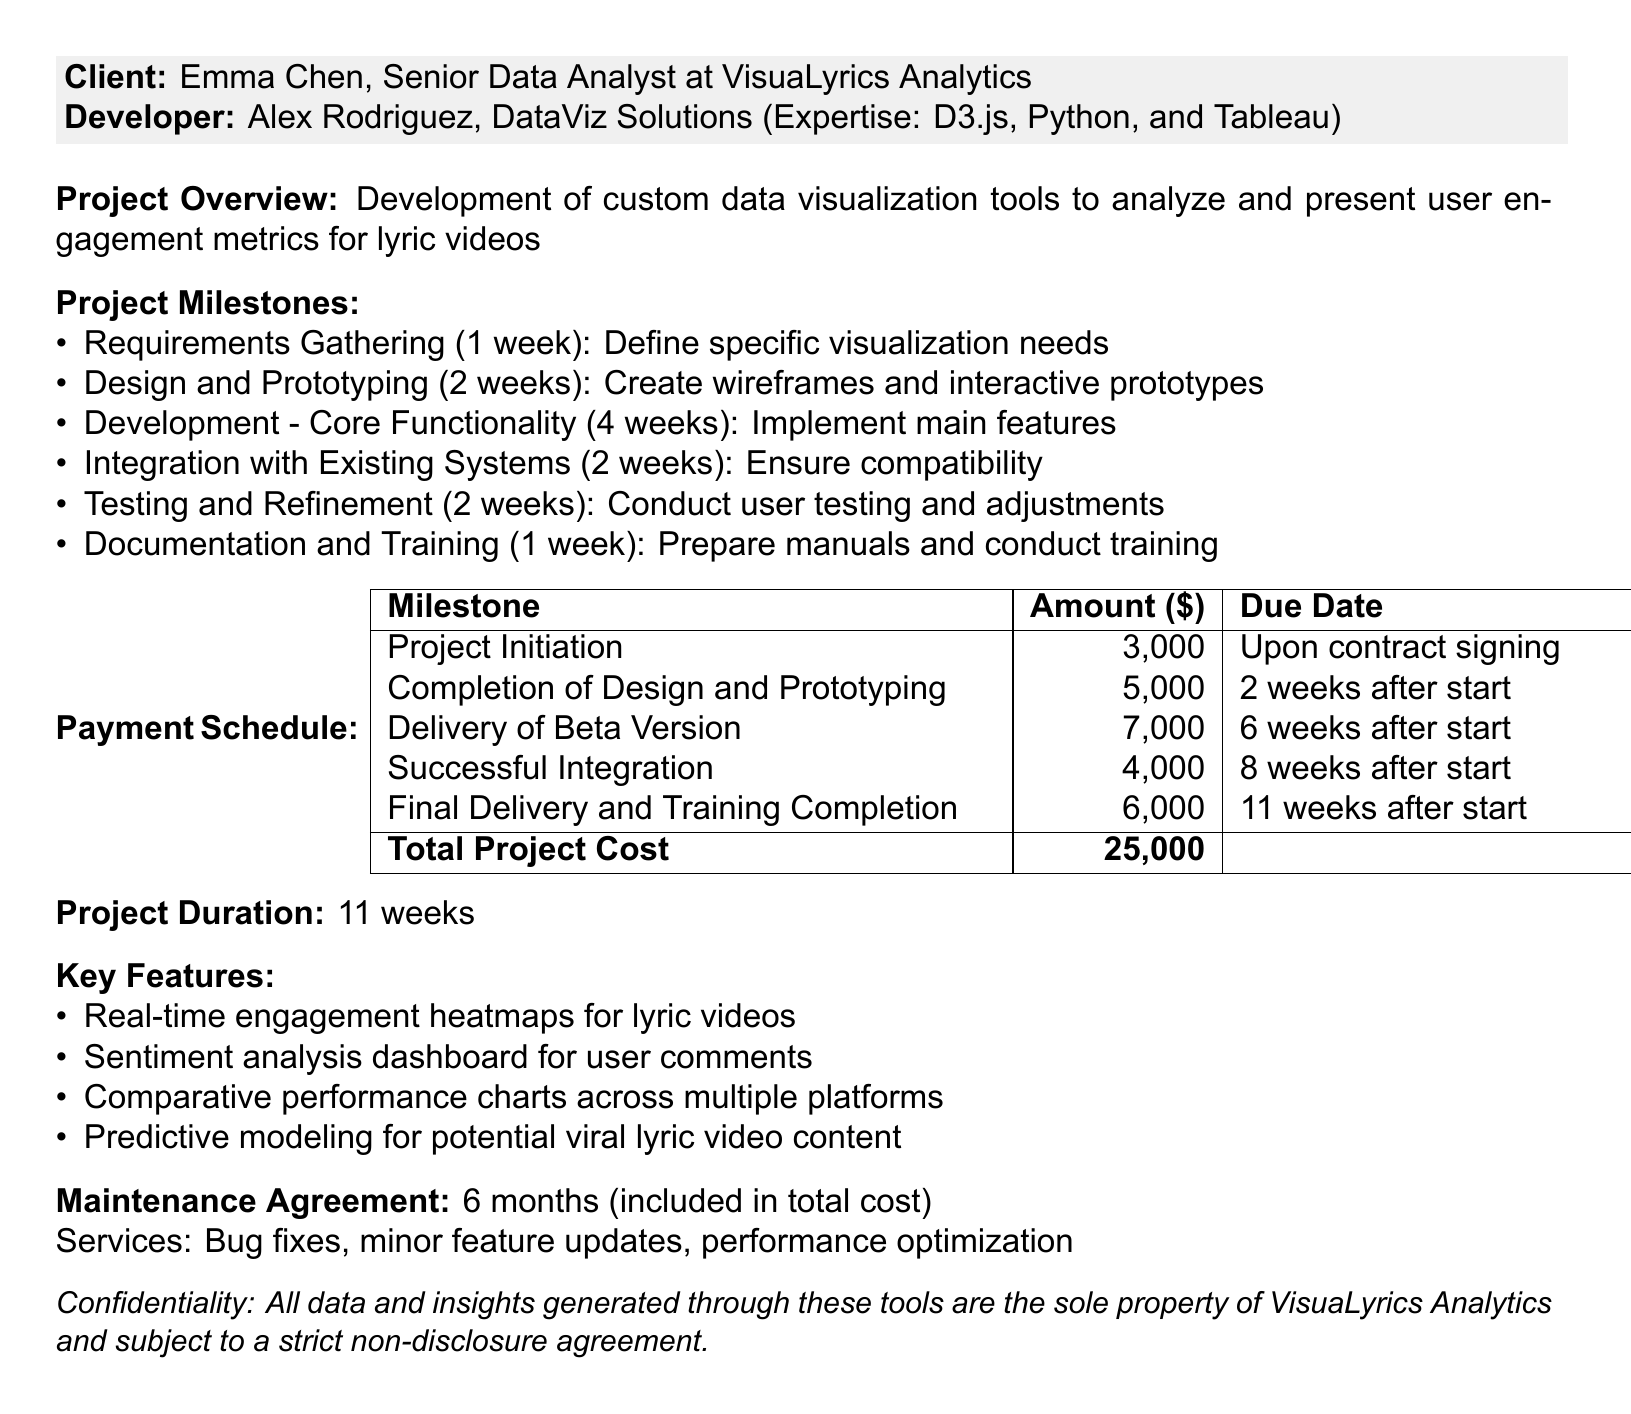What is the project title? The project title is a key identifier reflected at the start of the document.
Answer: Custom Data Visualization Tools for Lyric Video Engagement Analysis Who is the client? The client's name is mentioned in the document under the client section.
Answer: Emma Chen What is the total project cost? The total project cost is summarized at the end of the payment schedule section.
Answer: 25000 How long is the project duration? The project duration is listed at the end of the main project details.
Answer: 11 weeks What is the payment amount for the beta version delivery? The payment schedule specifically mentions the amount due for delivering the beta version.
Answer: 7000 Which technology is used for interactive visualizations? The technology stack section lists the tools used, including the specific purpose of each.
Answer: D3.js How many weeks are allocated for testing and refinement? The duration for this milestone is detailed in the milestones section of the document.
Answer: 2 weeks What is included in the maintenance agreement? The maintenance agreement outlines the services offered and their duration.
Answer: Bug fixes, minor feature updates, performance optimization What is the due date for the final delivery and training completion payment? The payment schedule clearly states this milestone's due date.
Answer: 11 weeks after project start 